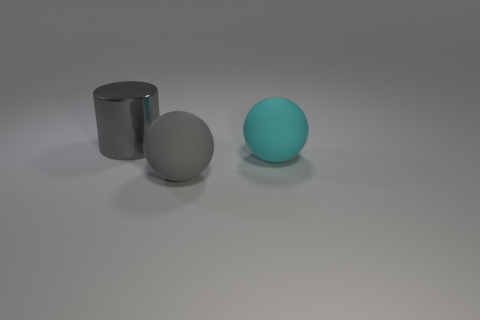Add 1 large purple cubes. How many objects exist? 4 Subtract 1 cylinders. How many cylinders are left? 0 Subtract 0 yellow blocks. How many objects are left? 3 Subtract all balls. How many objects are left? 1 Subtract all gray spheres. Subtract all purple cylinders. How many spheres are left? 1 Subtract all yellow balls. How many cyan cylinders are left? 0 Subtract all matte things. Subtract all gray spheres. How many objects are left? 0 Add 2 gray things. How many gray things are left? 4 Add 2 cylinders. How many cylinders exist? 3 